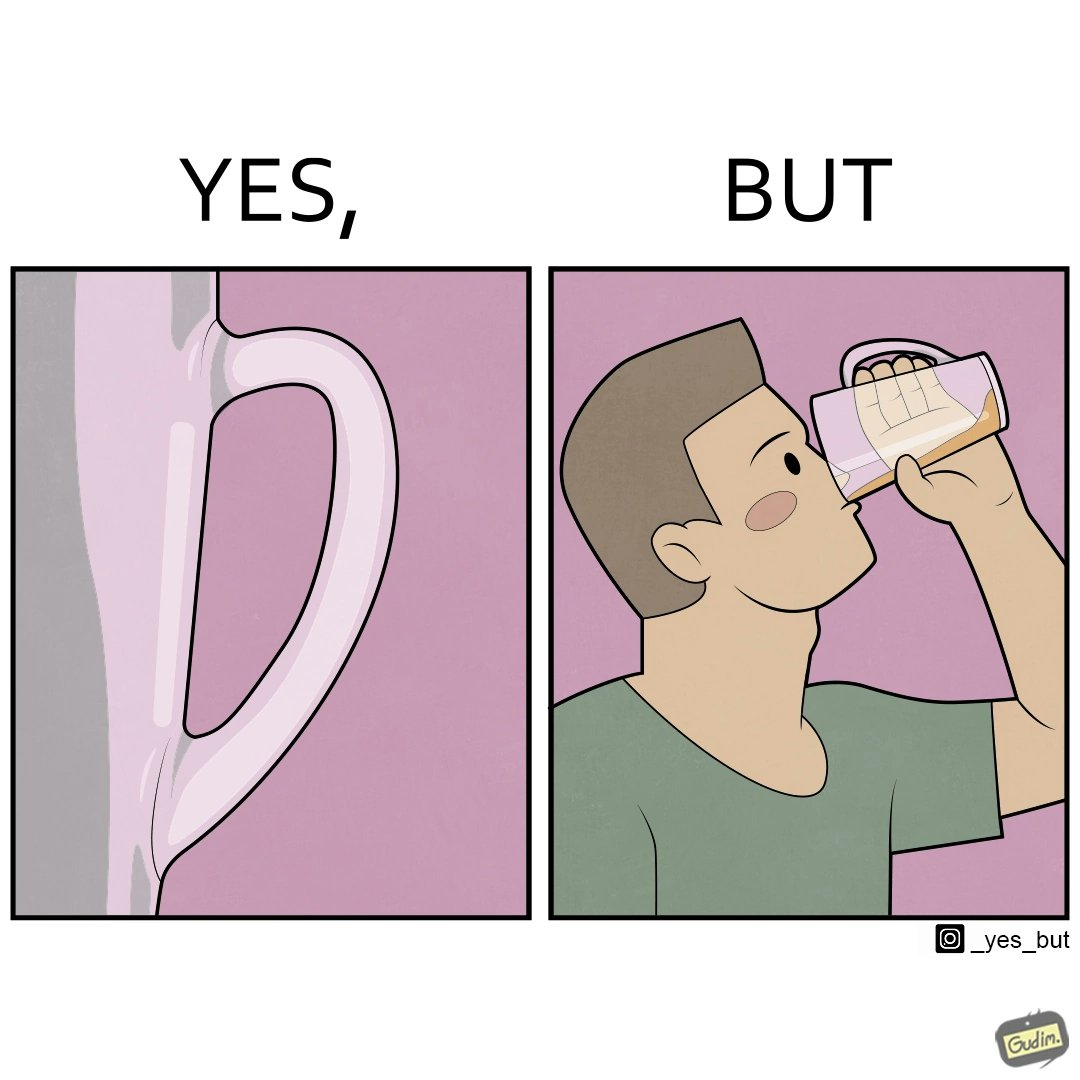Describe the satirical element in this image. This image is funny because even though the tumbler has a glass handle on it to facilitate holding, the person drinking from it doesn't use the handle making it redundant. 